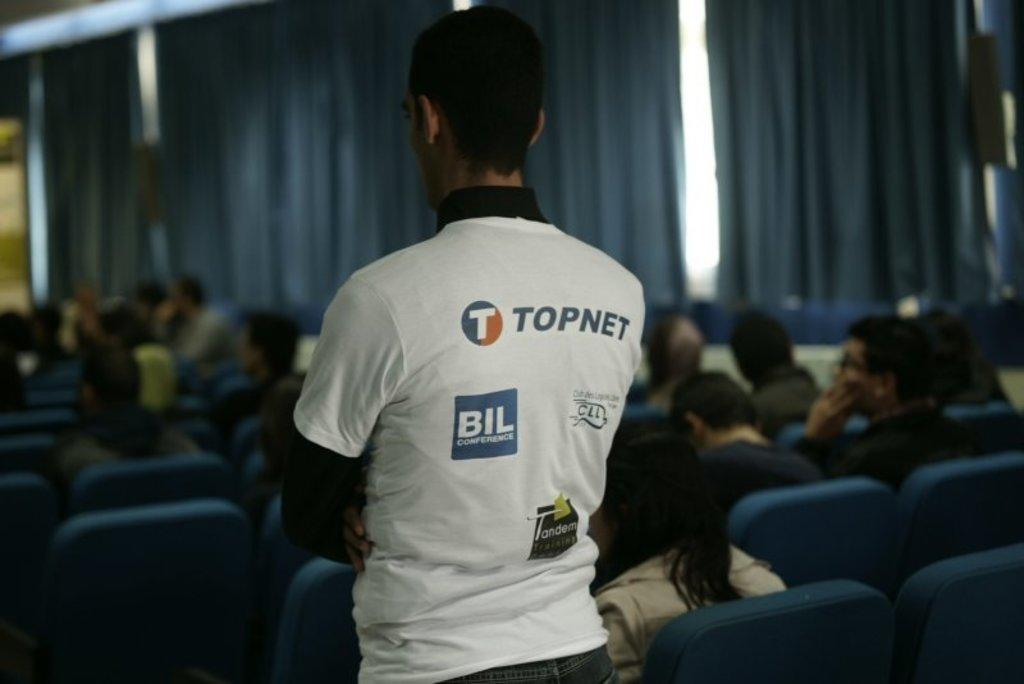Where is the setting of the image? The image is inside a room. Can you describe the person standing in the room? There is a person with a white t-shirt standing in the room. What are the other people in the room doing? There are other people sitting in the room. What color are the curtains at the back of the room? There are blue color curtains at the back of the room. What time of day is it in the image, considering the presence of an afternoon stream? There is no mention of an afternoon stream in the image, and therefore we cannot determine the time of day based on that information. 